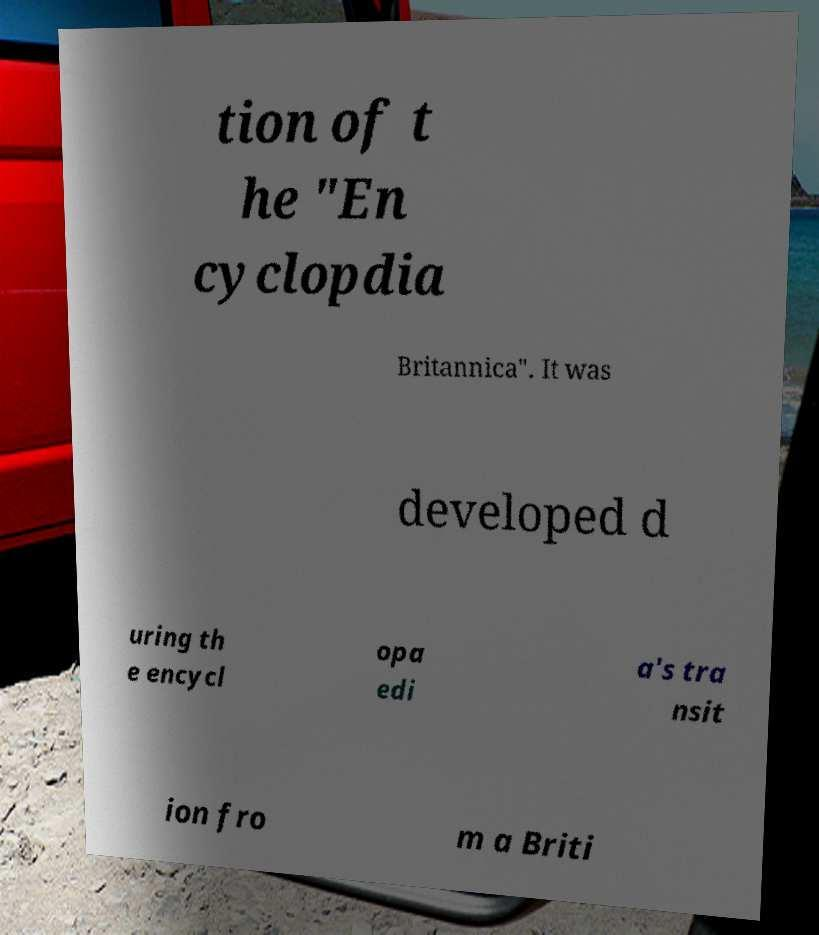For documentation purposes, I need the text within this image transcribed. Could you provide that? tion of t he "En cyclopdia Britannica". It was developed d uring th e encycl opa edi a's tra nsit ion fro m a Briti 